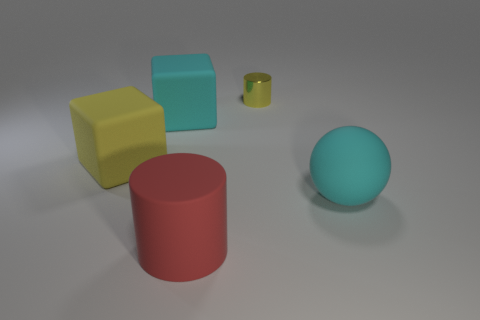Is there any other thing that is the same material as the small cylinder?
Provide a short and direct response. No. Are there any other things that are the same size as the shiny cylinder?
Your response must be concise. No. What shape is the red matte object that is the same size as the cyan matte ball?
Ensure brevity in your answer.  Cylinder. How many other things are there of the same color as the large matte ball?
Your answer should be very brief. 1. What material is the red object?
Offer a terse response. Rubber. How many other objects are there of the same material as the tiny thing?
Provide a succinct answer. 0. What is the size of the thing that is both behind the large yellow cube and on the left side of the small yellow thing?
Provide a short and direct response. Large. The large thing in front of the large thing that is on the right side of the small object is what shape?
Offer a very short reply. Cylinder. Is the number of yellow matte things that are behind the yellow cube the same as the number of big blocks?
Your answer should be compact. No. There is a small metallic cylinder; is its color the same as the large block to the left of the cyan rubber block?
Offer a terse response. Yes. 